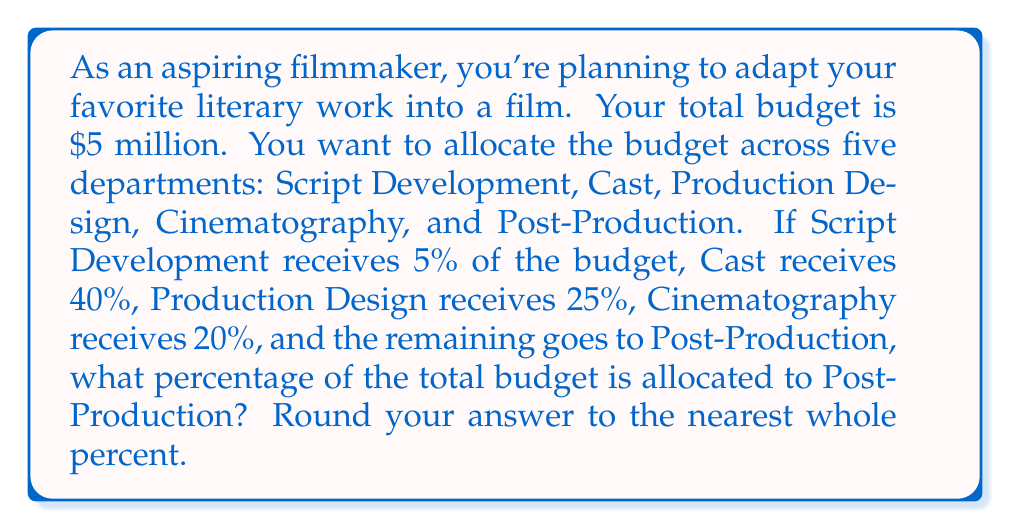Could you help me with this problem? Let's approach this step-by-step:

1) First, let's list the known percentages:
   - Script Development: 5%
   - Cast: 40%
   - Production Design: 25%
   - Cinematography: 20%

2) To find the percentage for Post-Production, we need to subtract the sum of these percentages from 100%:

   $$ \text{Post-Production} = 100\% - (\text{Script Development} + \text{Cast} + \text{Production Design} + \text{Cinematography}) $$

3) Let's substitute the values:

   $$ \text{Post-Production} = 100\% - (5\% + 40\% + 25\% + 20\%) $$

4) Now, let's add up the percentages inside the parentheses:

   $$ \text{Post-Production} = 100\% - 90\% $$

5) Finally, we can subtract:

   $$ \text{Post-Production} = 10\% $$

6) The question asks to round to the nearest whole percent, but 10% is already a whole number, so no rounding is necessary.
Answer: 10% 